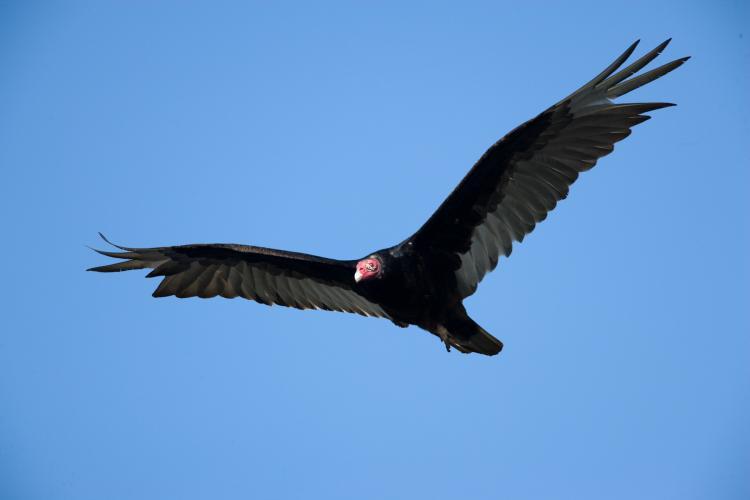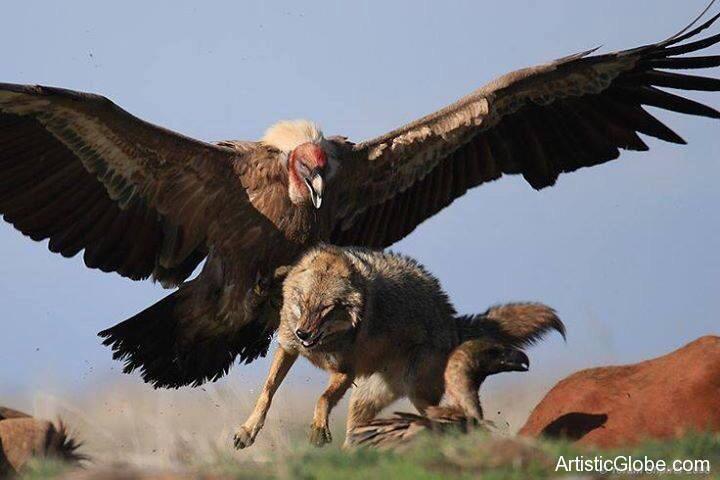The first image is the image on the left, the second image is the image on the right. Given the left and right images, does the statement "Two large birds have their wings extended, one in the air and one sitting." hold true? Answer yes or no. No. 